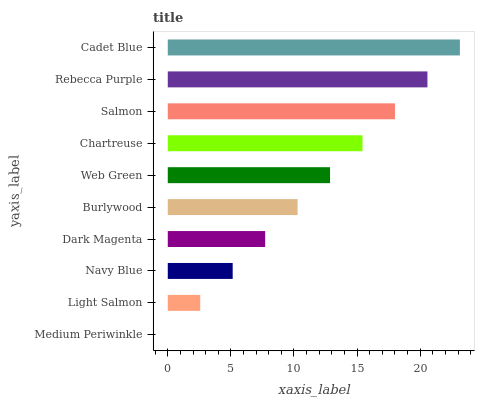Is Medium Periwinkle the minimum?
Answer yes or no. Yes. Is Cadet Blue the maximum?
Answer yes or no. Yes. Is Light Salmon the minimum?
Answer yes or no. No. Is Light Salmon the maximum?
Answer yes or no. No. Is Light Salmon greater than Medium Periwinkle?
Answer yes or no. Yes. Is Medium Periwinkle less than Light Salmon?
Answer yes or no. Yes. Is Medium Periwinkle greater than Light Salmon?
Answer yes or no. No. Is Light Salmon less than Medium Periwinkle?
Answer yes or no. No. Is Web Green the high median?
Answer yes or no. Yes. Is Burlywood the low median?
Answer yes or no. Yes. Is Dark Magenta the high median?
Answer yes or no. No. Is Rebecca Purple the low median?
Answer yes or no. No. 